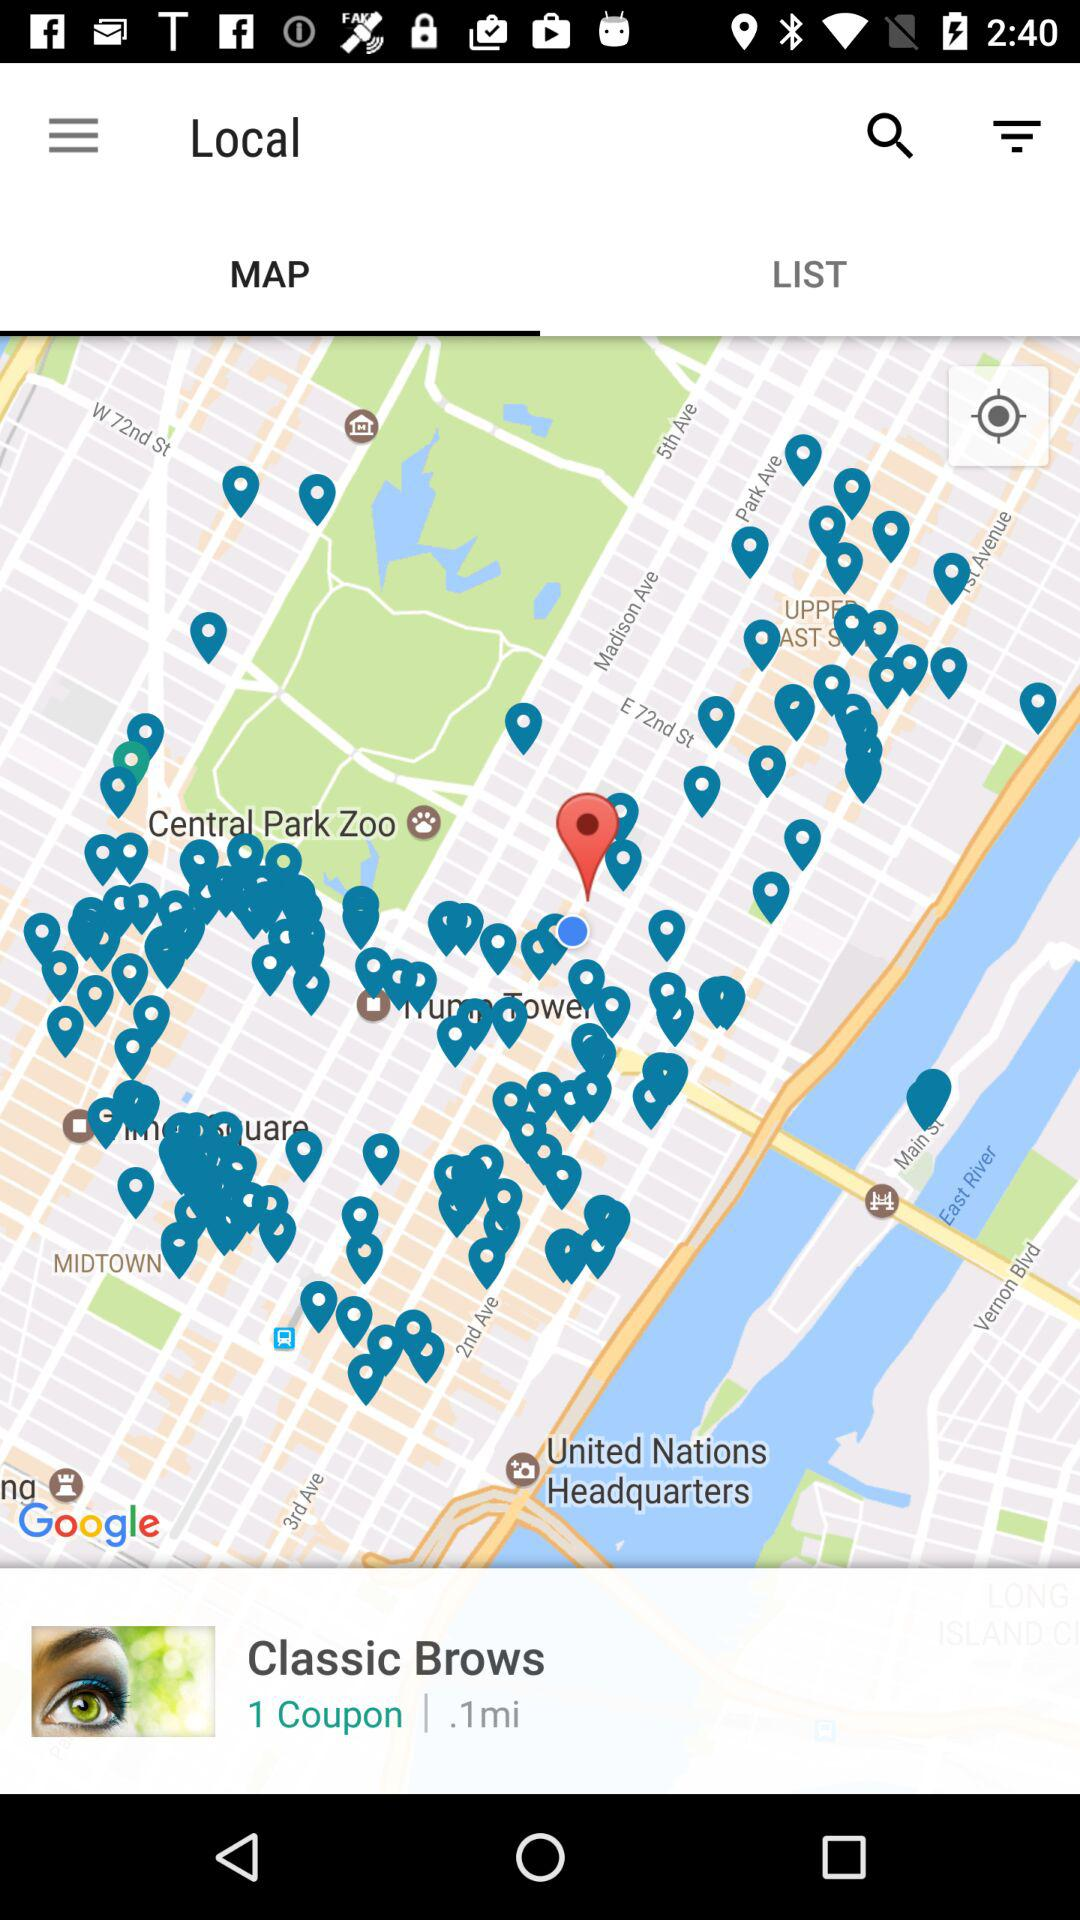How many coupons are there?
Answer the question using a single word or phrase. 1 